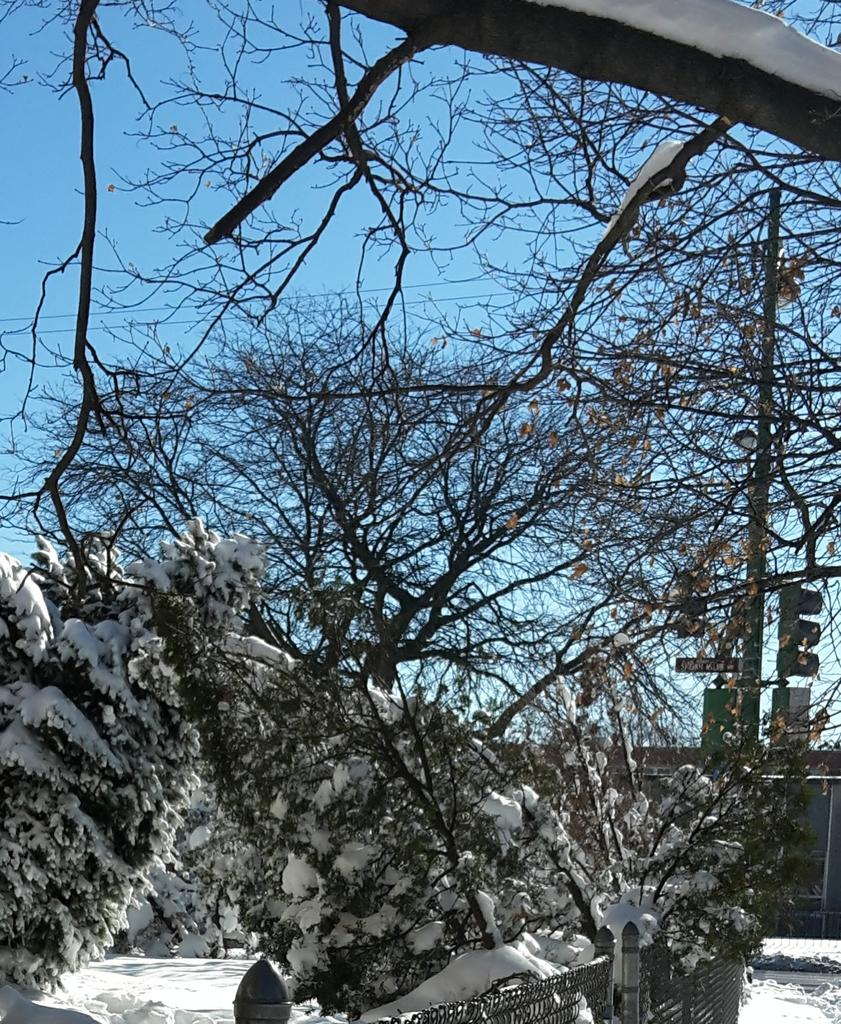What type of vegetation can be seen in the image? There are trees in the image. What is attached to the pole in the image? There is a traffic light on the pole. What is the purpose of the wires attached to the pole? The wires are likely for transmitting electricity or communication signals. What is the weather condition in the image? There is snow visible in the image, indicating a cold or wintery condition. What can be seen in the background of the image? The sky is visible in the background of the image. Where is the insurance company located in the image? There is no mention of an insurance company in the image. What type of drawer can be seen in the image? There are no drawers present in the image. 